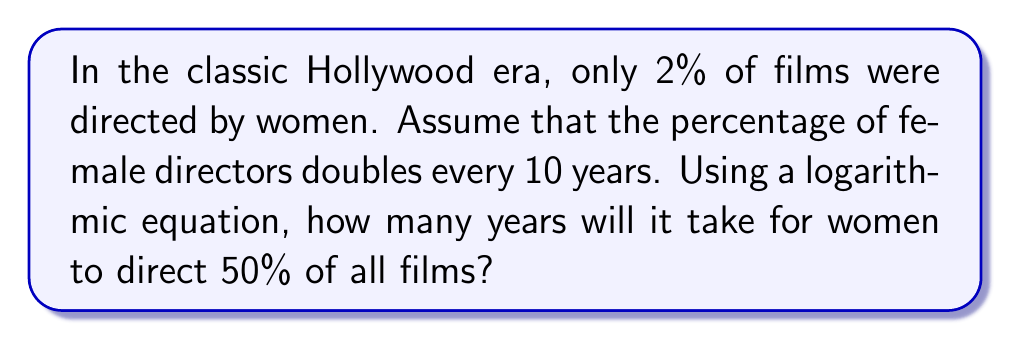Provide a solution to this math problem. Let's approach this step-by-step using logarithms:

1) Let $x$ be the number of 10-year periods needed to reach 50%.

2) We can express this as an exponential equation:
   $2 \cdot 2^x = 50$

3) Simplify the left side:
   $2^{x+1} = 50$

4) Take the logarithm (base 2) of both sides:
   $\log_2(2^{x+1}) = \log_2(50)$

5) Simplify the left side using the logarithm property $\log_a(a^x) = x$:
   $x + 1 = \log_2(50)$

6) Subtract 1 from both sides:
   $x = \log_2(50) - 1$

7) Calculate $\log_2(50)$:
   $\log_2(50) \approx 5.64386$

8) Subtract 1:
   $x \approx 4.64386$

9) Remember, $x$ is the number of 10-year periods. Multiply by 10 to get the number of years:
   Years $= 10x \approx 46.4386$

10) Round up to the nearest year, as we can't have a fractional year.
Answer: 47 years 